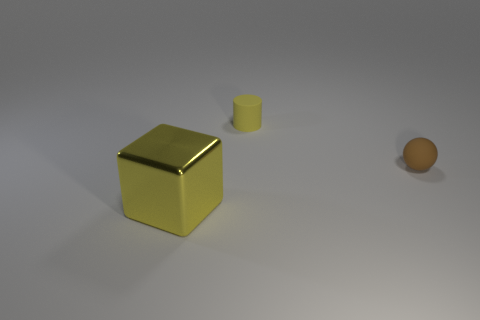Add 2 blocks. How many objects exist? 5 Subtract all blocks. How many objects are left? 2 Subtract 0 purple cylinders. How many objects are left? 3 Subtract all brown things. Subtract all tiny rubber cylinders. How many objects are left? 1 Add 1 large blocks. How many large blocks are left? 2 Add 3 small brown balls. How many small brown balls exist? 4 